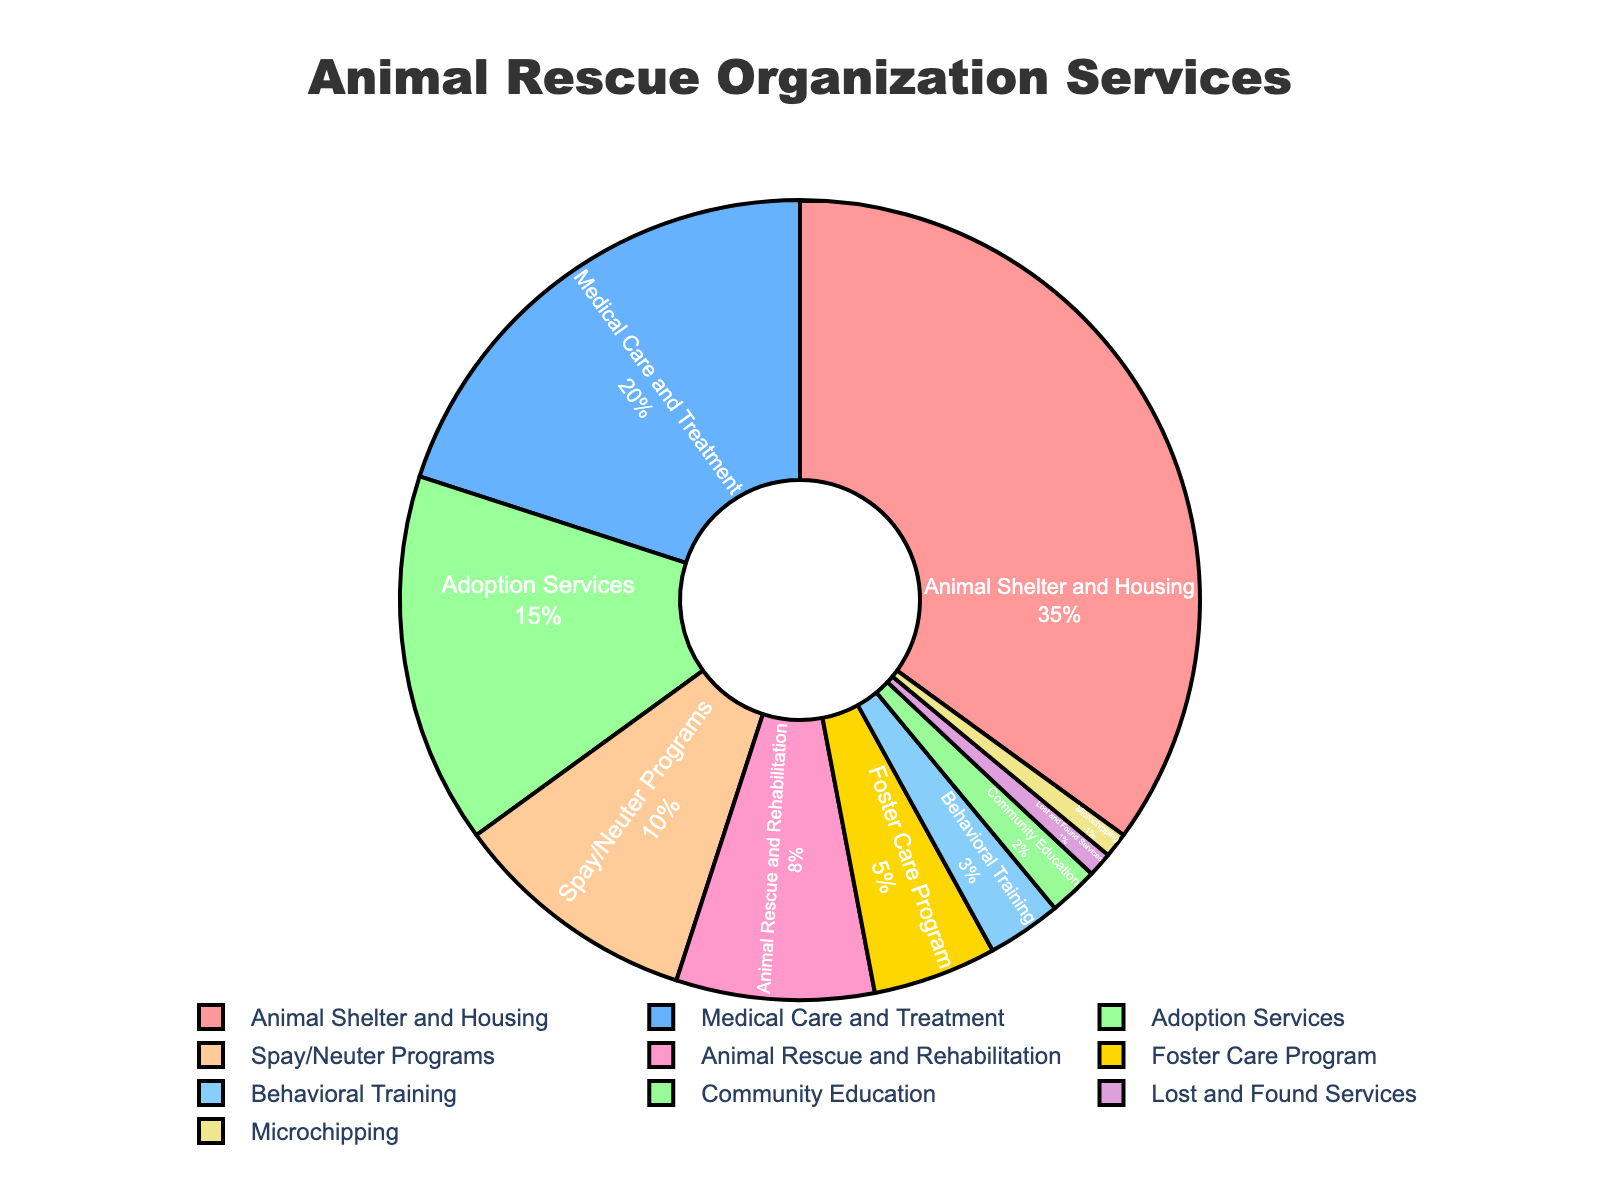Which service type has the highest percentage? The largest section of the pie chart is labeled "Animal Shelter and Housing," and the percentage shown is 35%.
Answer: Animal Shelter and Housing What is the total percentage of services related to medical care? Sum the percentages for "Medical Care and Treatment" (20%) and "Spay/Neuter Programs" (10%). 20% + 10% = 30%.
Answer: 30% Which two services combined make up exactly half of the organization's services? "Animal Shelter and Housing" (35%) and "Medical Care and Treatment" (20%) add up to 55%, which is over 50%. "Animal Shelter and Housing" and "Adoption Services" add up to 50%.
Answer: Animal Shelter and Housing and Adoption Services How much greater is the percentage of "Animal Shelter and Housing" compared to "Adoption Services"? Subtract the percentage of "Adoption Services" (15%) from "Animal Shelter and Housing" (35%). 35% - 15% = 20%.
Answer: 20% Which service is represented by a yellow section in the pie chart? The yellow section of the pie chart corresponds to the label "Foster Care Program."
Answer: Foster Care Program What percentage of the services are dedicated to education and training combined? Sum the percentages for "Behavioral Training" (3%) and "Community Education" (2%). 3% + 2% = 5%.
Answer: 5% How many service types have a percentage lower than 5%? Identify the service types with percentages lower than 5%: "Foster Care Program" (5%), "Behavioral Training" (3%), "Community Education" (2%), "Lost and Found Services" (1%), and "Microchipping" (1%). There are five categories, but only four are below 5%.
Answer: Four What's the combined percentage of the services related to animal rescue and care? Sum the percentages for "Animal Rescue and Rehabilitation" (8%), "Medical Care and Treatment" (20%), and "Animal Shelter and Housing" (35%). 8% + 20% + 35% = 63%.
Answer: 63% Is the percentage of "Spay/Neuter Programs" greater than "Behavioral Training" and "Community Education" combined? Add the percentages of "Behavioral Training" (3%) and "Community Education" (2%). Their combined percentage is 3% + 2% = 5%. The percentage for "Spay/Neuter Programs" is 10%, which is greater than 5%.
Answer: Yes What is the percentage difference between the service with the highest and the service with the lowest proportion? The highest proportion is for "Animal Shelter and Housing" (35%) and the lowest is for both "Lost and Found Services" and "Microchipping" (1%). The difference is 35% - 1% = 34%.
Answer: 34% 